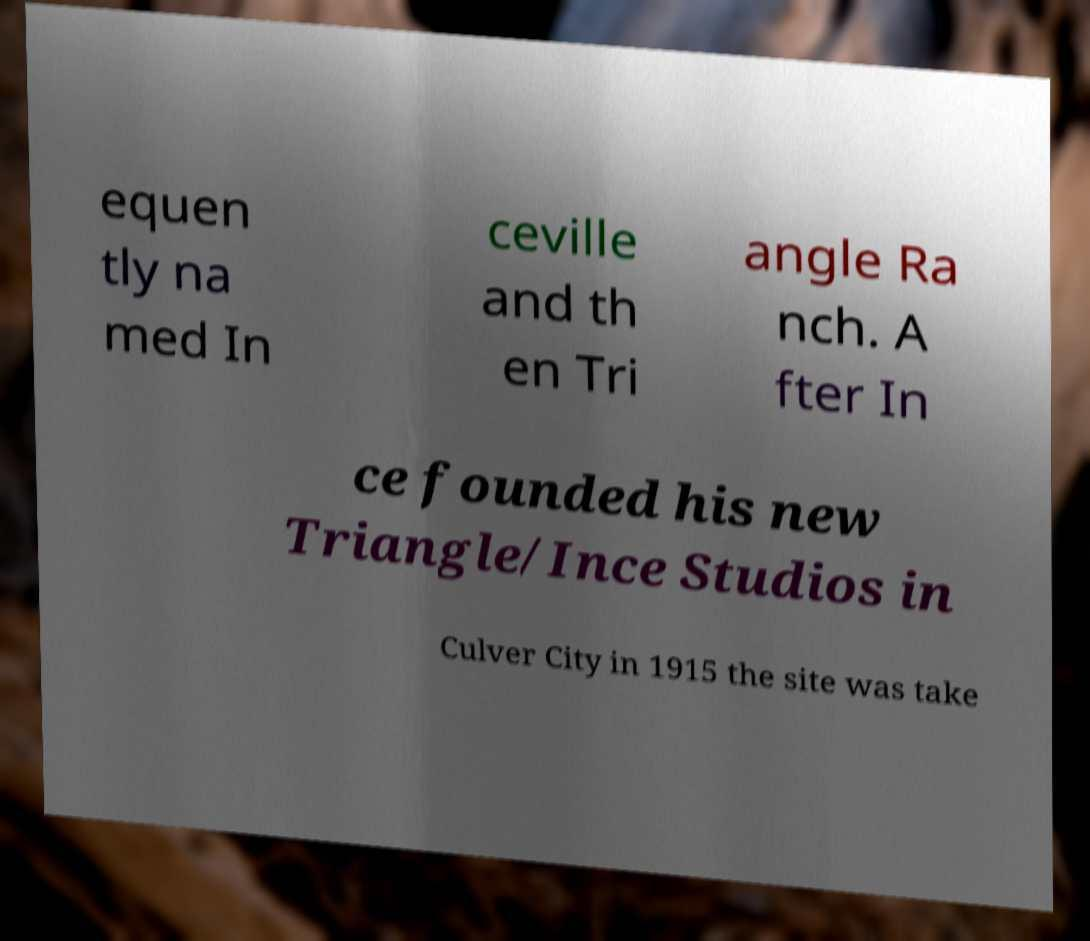Can you read and provide the text displayed in the image?This photo seems to have some interesting text. Can you extract and type it out for me? equen tly na med In ceville and th en Tri angle Ra nch. A fter In ce founded his new Triangle/Ince Studios in Culver City in 1915 the site was take 